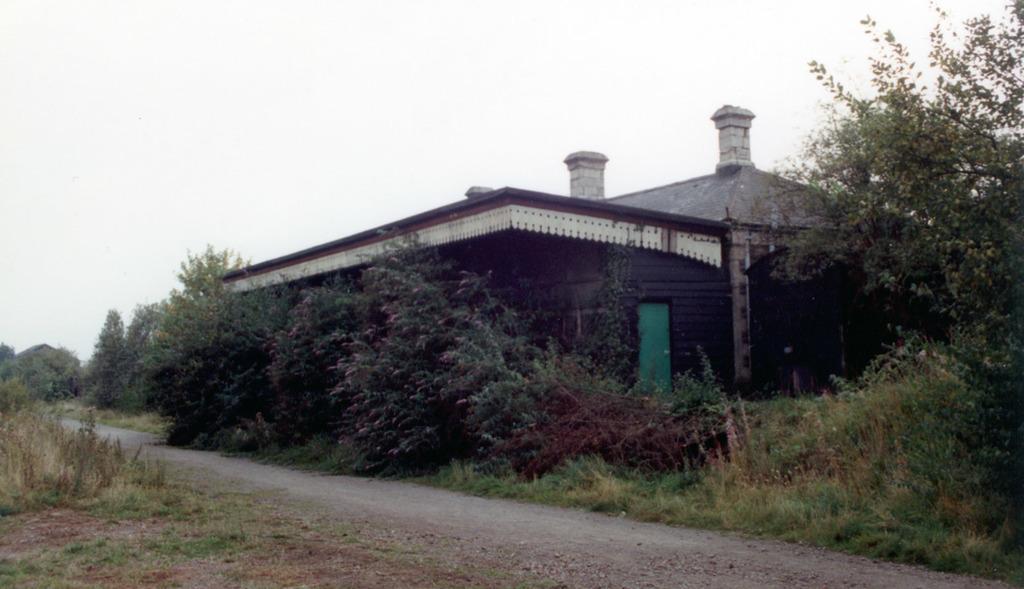Could you give a brief overview of what you see in this image? In this image we can see grass, plants, house, door, pillars, and trees. In the background there is sky. 